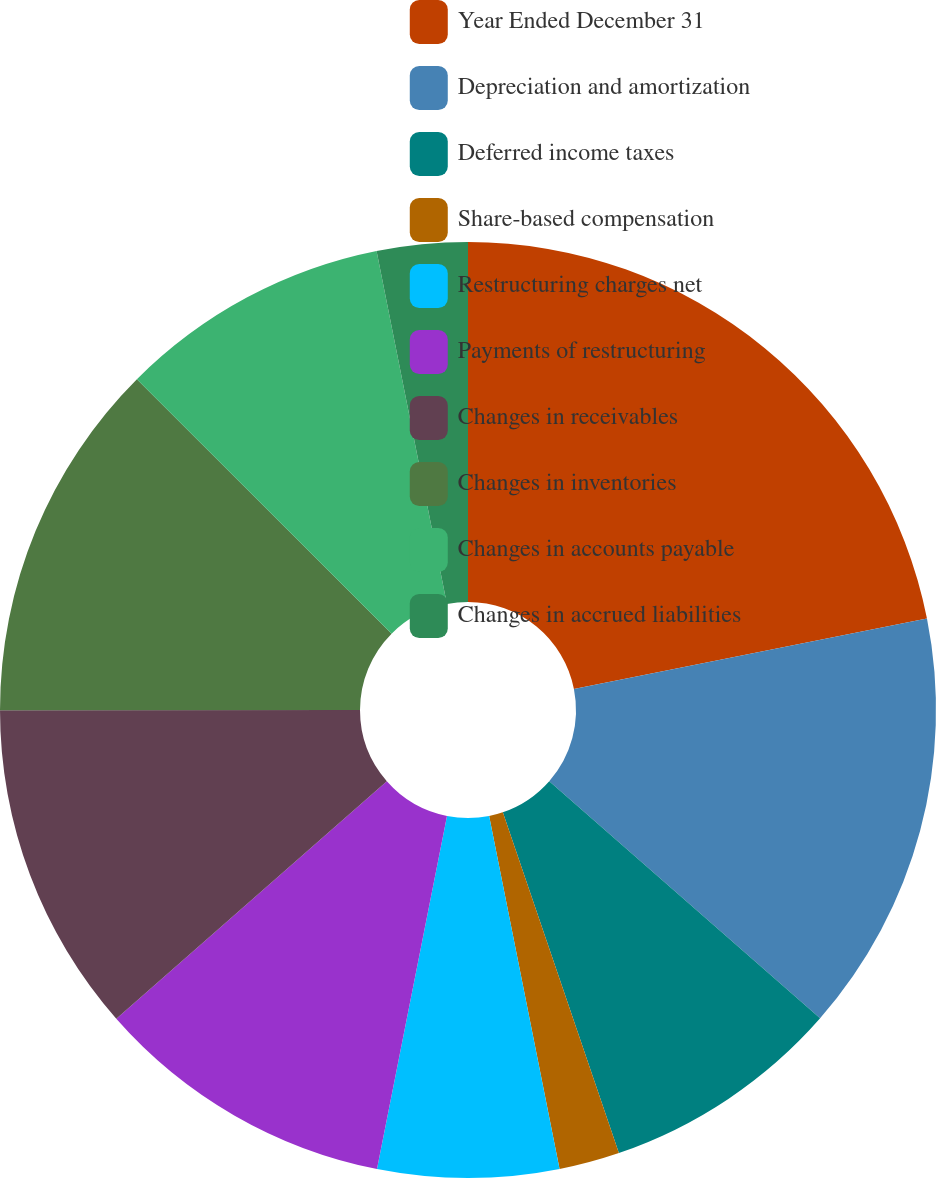<chart> <loc_0><loc_0><loc_500><loc_500><pie_chart><fcel>Year Ended December 31<fcel>Depreciation and amortization<fcel>Deferred income taxes<fcel>Share-based compensation<fcel>Restructuring charges net<fcel>Payments of restructuring<fcel>Changes in receivables<fcel>Changes in inventories<fcel>Changes in accounts payable<fcel>Changes in accrued liabilities<nl><fcel>21.87%<fcel>14.58%<fcel>8.33%<fcel>2.09%<fcel>6.25%<fcel>10.42%<fcel>11.46%<fcel>12.5%<fcel>9.38%<fcel>3.13%<nl></chart> 